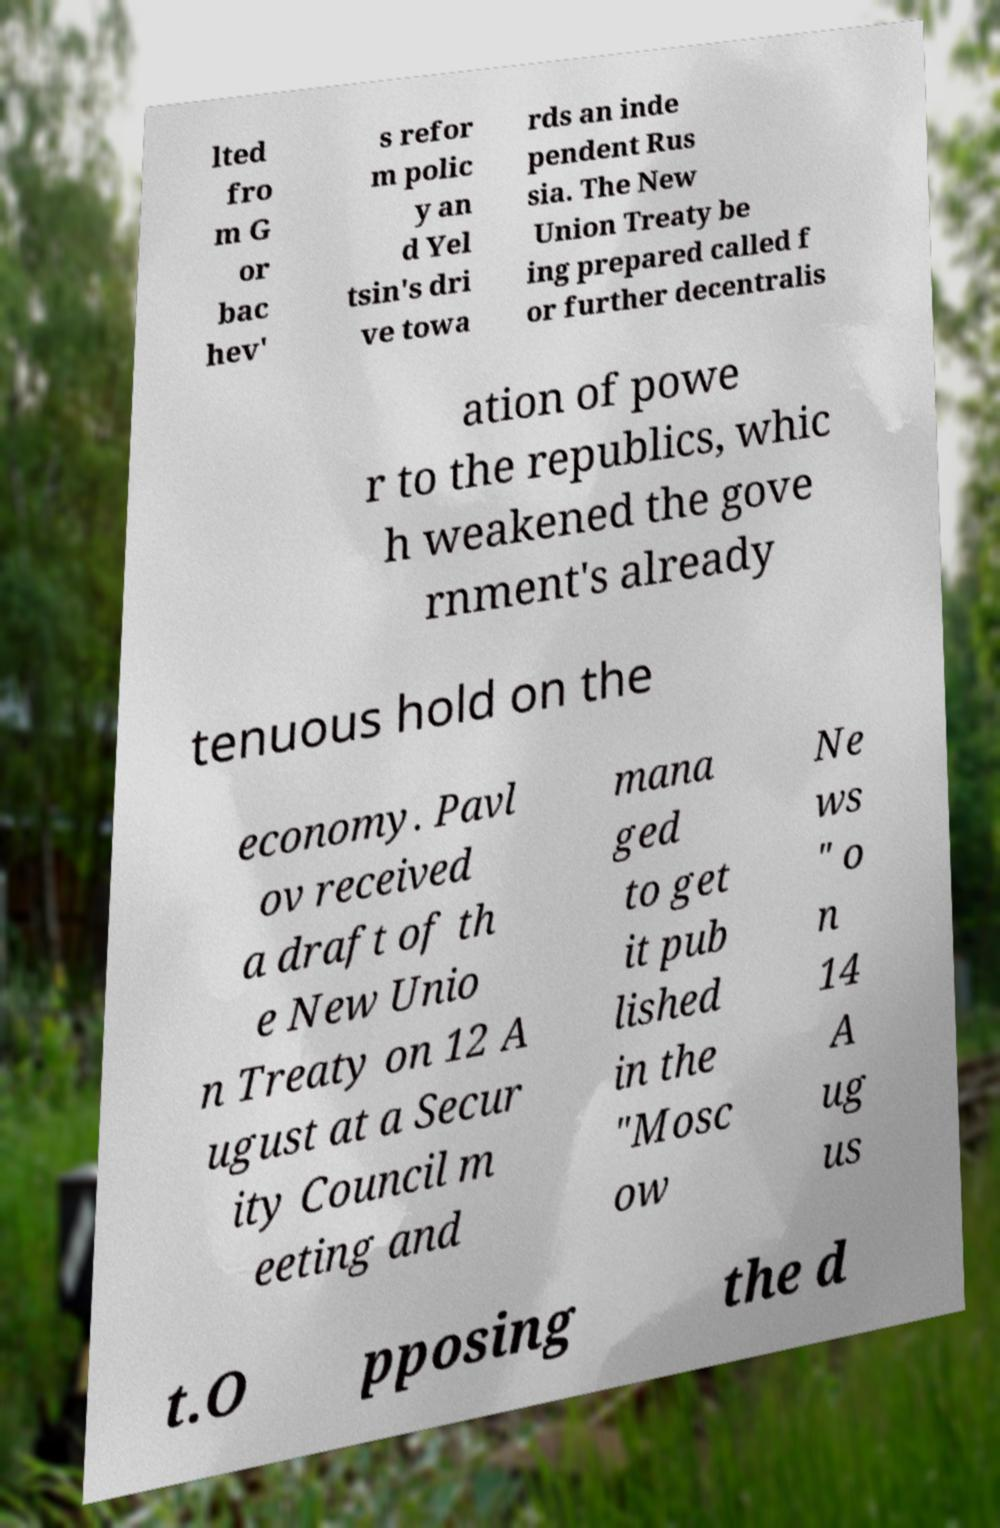What messages or text are displayed in this image? I need them in a readable, typed format. lted fro m G or bac hev' s refor m polic y an d Yel tsin's dri ve towa rds an inde pendent Rus sia. The New Union Treaty be ing prepared called f or further decentralis ation of powe r to the republics, whic h weakened the gove rnment's already tenuous hold on the economy. Pavl ov received a draft of th e New Unio n Treaty on 12 A ugust at a Secur ity Council m eeting and mana ged to get it pub lished in the "Mosc ow Ne ws " o n 14 A ug us t.O pposing the d 